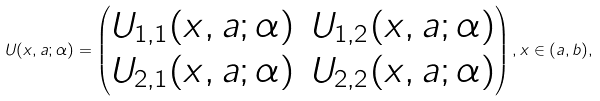<formula> <loc_0><loc_0><loc_500><loc_500>U ( x , a ; \alpha ) = \begin{pmatrix} U _ { 1 , 1 } ( x , a ; \alpha ) & U _ { 1 , 2 } ( x , a ; \alpha ) \\ U _ { 2 , 1 } ( x , a ; \alpha ) & U _ { 2 , 2 } ( x , a ; \alpha ) \end{pmatrix} , x \in ( a , b ) ,</formula> 